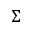Convert formula to latex. <formula><loc_0><loc_0><loc_500><loc_500>\Sigma</formula> 